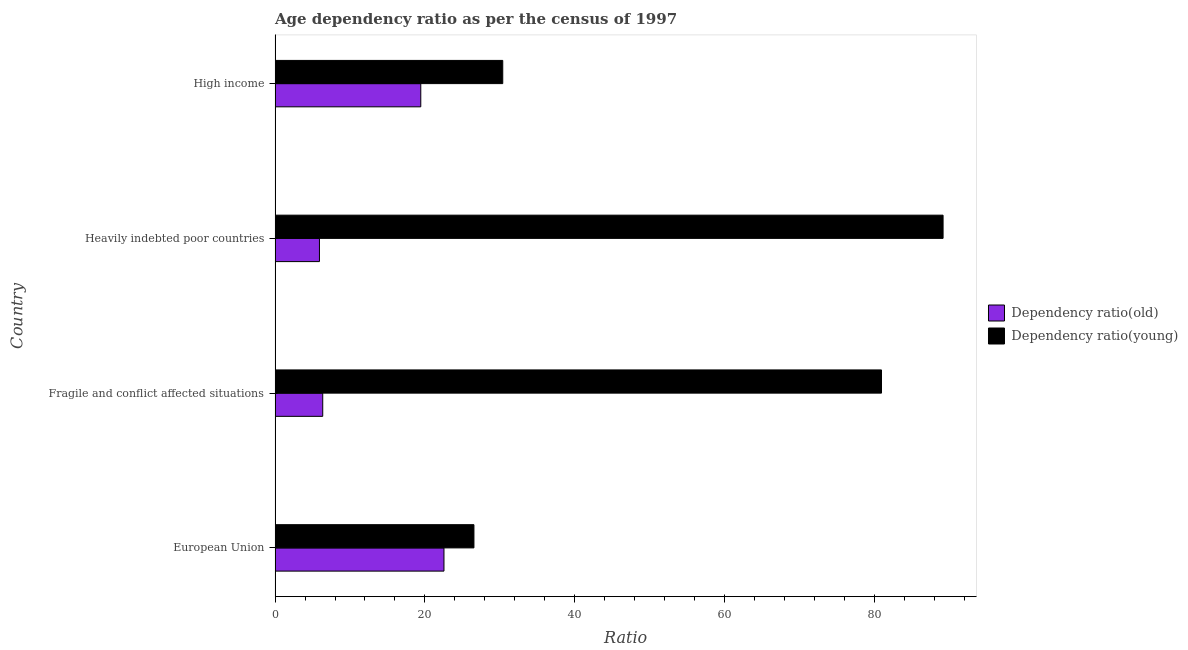How many different coloured bars are there?
Give a very brief answer. 2. How many groups of bars are there?
Your answer should be very brief. 4. Are the number of bars per tick equal to the number of legend labels?
Make the answer very short. Yes. Are the number of bars on each tick of the Y-axis equal?
Offer a terse response. Yes. How many bars are there on the 3rd tick from the top?
Give a very brief answer. 2. How many bars are there on the 4th tick from the bottom?
Give a very brief answer. 2. What is the label of the 3rd group of bars from the top?
Your answer should be very brief. Fragile and conflict affected situations. What is the age dependency ratio(young) in High income?
Provide a short and direct response. 30.4. Across all countries, what is the maximum age dependency ratio(young)?
Your answer should be very brief. 89.2. Across all countries, what is the minimum age dependency ratio(young)?
Provide a succinct answer. 26.55. In which country was the age dependency ratio(old) maximum?
Your answer should be very brief. European Union. What is the total age dependency ratio(old) in the graph?
Keep it short and to the point. 54.3. What is the difference between the age dependency ratio(old) in Fragile and conflict affected situations and that in Heavily indebted poor countries?
Offer a terse response. 0.44. What is the difference between the age dependency ratio(old) in High income and the age dependency ratio(young) in Fragile and conflict affected situations?
Give a very brief answer. -61.52. What is the average age dependency ratio(old) per country?
Your answer should be compact. 13.57. What is the difference between the age dependency ratio(old) and age dependency ratio(young) in Fragile and conflict affected situations?
Make the answer very short. -74.61. What is the ratio of the age dependency ratio(young) in Fragile and conflict affected situations to that in Heavily indebted poor countries?
Your response must be concise. 0.91. Is the difference between the age dependency ratio(young) in Fragile and conflict affected situations and Heavily indebted poor countries greater than the difference between the age dependency ratio(old) in Fragile and conflict affected situations and Heavily indebted poor countries?
Ensure brevity in your answer.  No. What is the difference between the highest and the second highest age dependency ratio(old)?
Your response must be concise. 3.1. What is the difference between the highest and the lowest age dependency ratio(old)?
Give a very brief answer. 16.63. In how many countries, is the age dependency ratio(old) greater than the average age dependency ratio(old) taken over all countries?
Your answer should be very brief. 2. Is the sum of the age dependency ratio(young) in Fragile and conflict affected situations and Heavily indebted poor countries greater than the maximum age dependency ratio(old) across all countries?
Offer a very short reply. Yes. What does the 2nd bar from the top in High income represents?
Offer a terse response. Dependency ratio(old). What does the 1st bar from the bottom in Fragile and conflict affected situations represents?
Your answer should be compact. Dependency ratio(old). How many bars are there?
Offer a very short reply. 8. Are all the bars in the graph horizontal?
Your answer should be very brief. Yes. How many countries are there in the graph?
Your response must be concise. 4. What is the difference between two consecutive major ticks on the X-axis?
Provide a short and direct response. 20. Are the values on the major ticks of X-axis written in scientific E-notation?
Provide a succinct answer. No. Does the graph contain any zero values?
Provide a short and direct response. No. Does the graph contain grids?
Give a very brief answer. No. Where does the legend appear in the graph?
Keep it short and to the point. Center right. How many legend labels are there?
Your answer should be compact. 2. How are the legend labels stacked?
Ensure brevity in your answer.  Vertical. What is the title of the graph?
Provide a succinct answer. Age dependency ratio as per the census of 1997. What is the label or title of the X-axis?
Make the answer very short. Ratio. What is the Ratio of Dependency ratio(old) in European Union?
Provide a short and direct response. 22.55. What is the Ratio of Dependency ratio(young) in European Union?
Your answer should be very brief. 26.55. What is the Ratio of Dependency ratio(old) in Fragile and conflict affected situations?
Offer a terse response. 6.36. What is the Ratio of Dependency ratio(young) in Fragile and conflict affected situations?
Your answer should be very brief. 80.97. What is the Ratio of Dependency ratio(old) in Heavily indebted poor countries?
Give a very brief answer. 5.92. What is the Ratio of Dependency ratio(young) in Heavily indebted poor countries?
Make the answer very short. 89.2. What is the Ratio of Dependency ratio(old) in High income?
Offer a terse response. 19.46. What is the Ratio of Dependency ratio(young) in High income?
Provide a succinct answer. 30.4. Across all countries, what is the maximum Ratio in Dependency ratio(old)?
Ensure brevity in your answer.  22.55. Across all countries, what is the maximum Ratio of Dependency ratio(young)?
Provide a succinct answer. 89.2. Across all countries, what is the minimum Ratio of Dependency ratio(old)?
Give a very brief answer. 5.92. Across all countries, what is the minimum Ratio of Dependency ratio(young)?
Offer a terse response. 26.55. What is the total Ratio of Dependency ratio(old) in the graph?
Ensure brevity in your answer.  54.3. What is the total Ratio in Dependency ratio(young) in the graph?
Provide a short and direct response. 227.12. What is the difference between the Ratio of Dependency ratio(old) in European Union and that in Fragile and conflict affected situations?
Your response must be concise. 16.19. What is the difference between the Ratio in Dependency ratio(young) in European Union and that in Fragile and conflict affected situations?
Your answer should be very brief. -54.42. What is the difference between the Ratio in Dependency ratio(old) in European Union and that in Heavily indebted poor countries?
Make the answer very short. 16.63. What is the difference between the Ratio of Dependency ratio(young) in European Union and that in Heavily indebted poor countries?
Ensure brevity in your answer.  -62.64. What is the difference between the Ratio of Dependency ratio(old) in European Union and that in High income?
Offer a very short reply. 3.1. What is the difference between the Ratio in Dependency ratio(young) in European Union and that in High income?
Give a very brief answer. -3.85. What is the difference between the Ratio of Dependency ratio(old) in Fragile and conflict affected situations and that in Heavily indebted poor countries?
Offer a terse response. 0.44. What is the difference between the Ratio of Dependency ratio(young) in Fragile and conflict affected situations and that in Heavily indebted poor countries?
Your answer should be compact. -8.22. What is the difference between the Ratio in Dependency ratio(old) in Fragile and conflict affected situations and that in High income?
Provide a succinct answer. -13.09. What is the difference between the Ratio of Dependency ratio(young) in Fragile and conflict affected situations and that in High income?
Provide a short and direct response. 50.57. What is the difference between the Ratio in Dependency ratio(old) in Heavily indebted poor countries and that in High income?
Make the answer very short. -13.53. What is the difference between the Ratio of Dependency ratio(young) in Heavily indebted poor countries and that in High income?
Your response must be concise. 58.8. What is the difference between the Ratio of Dependency ratio(old) in European Union and the Ratio of Dependency ratio(young) in Fragile and conflict affected situations?
Make the answer very short. -58.42. What is the difference between the Ratio in Dependency ratio(old) in European Union and the Ratio in Dependency ratio(young) in Heavily indebted poor countries?
Provide a short and direct response. -66.64. What is the difference between the Ratio in Dependency ratio(old) in European Union and the Ratio in Dependency ratio(young) in High income?
Your answer should be compact. -7.85. What is the difference between the Ratio of Dependency ratio(old) in Fragile and conflict affected situations and the Ratio of Dependency ratio(young) in Heavily indebted poor countries?
Keep it short and to the point. -82.83. What is the difference between the Ratio in Dependency ratio(old) in Fragile and conflict affected situations and the Ratio in Dependency ratio(young) in High income?
Offer a terse response. -24.04. What is the difference between the Ratio of Dependency ratio(old) in Heavily indebted poor countries and the Ratio of Dependency ratio(young) in High income?
Provide a short and direct response. -24.48. What is the average Ratio in Dependency ratio(old) per country?
Your response must be concise. 13.57. What is the average Ratio in Dependency ratio(young) per country?
Your response must be concise. 56.78. What is the difference between the Ratio of Dependency ratio(old) and Ratio of Dependency ratio(young) in European Union?
Your answer should be compact. -4. What is the difference between the Ratio in Dependency ratio(old) and Ratio in Dependency ratio(young) in Fragile and conflict affected situations?
Make the answer very short. -74.61. What is the difference between the Ratio in Dependency ratio(old) and Ratio in Dependency ratio(young) in Heavily indebted poor countries?
Keep it short and to the point. -83.27. What is the difference between the Ratio of Dependency ratio(old) and Ratio of Dependency ratio(young) in High income?
Keep it short and to the point. -10.94. What is the ratio of the Ratio in Dependency ratio(old) in European Union to that in Fragile and conflict affected situations?
Give a very brief answer. 3.54. What is the ratio of the Ratio in Dependency ratio(young) in European Union to that in Fragile and conflict affected situations?
Provide a succinct answer. 0.33. What is the ratio of the Ratio in Dependency ratio(old) in European Union to that in Heavily indebted poor countries?
Keep it short and to the point. 3.81. What is the ratio of the Ratio of Dependency ratio(young) in European Union to that in Heavily indebted poor countries?
Ensure brevity in your answer.  0.3. What is the ratio of the Ratio in Dependency ratio(old) in European Union to that in High income?
Your answer should be compact. 1.16. What is the ratio of the Ratio of Dependency ratio(young) in European Union to that in High income?
Make the answer very short. 0.87. What is the ratio of the Ratio of Dependency ratio(old) in Fragile and conflict affected situations to that in Heavily indebted poor countries?
Ensure brevity in your answer.  1.07. What is the ratio of the Ratio of Dependency ratio(young) in Fragile and conflict affected situations to that in Heavily indebted poor countries?
Offer a very short reply. 0.91. What is the ratio of the Ratio of Dependency ratio(old) in Fragile and conflict affected situations to that in High income?
Ensure brevity in your answer.  0.33. What is the ratio of the Ratio in Dependency ratio(young) in Fragile and conflict affected situations to that in High income?
Your answer should be compact. 2.66. What is the ratio of the Ratio of Dependency ratio(old) in Heavily indebted poor countries to that in High income?
Ensure brevity in your answer.  0.3. What is the ratio of the Ratio in Dependency ratio(young) in Heavily indebted poor countries to that in High income?
Offer a very short reply. 2.93. What is the difference between the highest and the second highest Ratio of Dependency ratio(old)?
Provide a short and direct response. 3.1. What is the difference between the highest and the second highest Ratio in Dependency ratio(young)?
Provide a short and direct response. 8.22. What is the difference between the highest and the lowest Ratio of Dependency ratio(old)?
Your response must be concise. 16.63. What is the difference between the highest and the lowest Ratio of Dependency ratio(young)?
Make the answer very short. 62.64. 